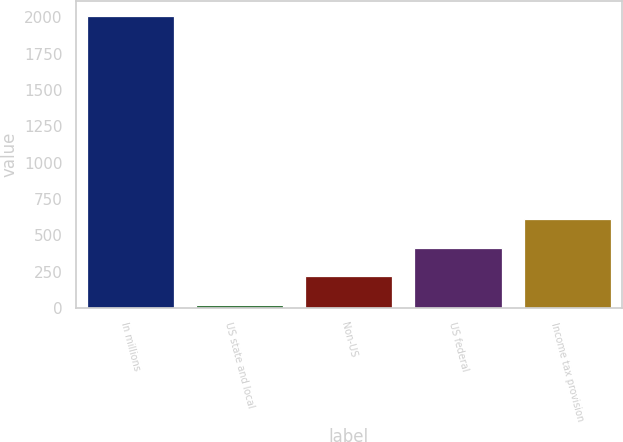Convert chart. <chart><loc_0><loc_0><loc_500><loc_500><bar_chart><fcel>In millions<fcel>US state and local<fcel>Non-US<fcel>US federal<fcel>Income tax provision<nl><fcel>2011<fcel>19<fcel>218.2<fcel>417.4<fcel>616.6<nl></chart> 